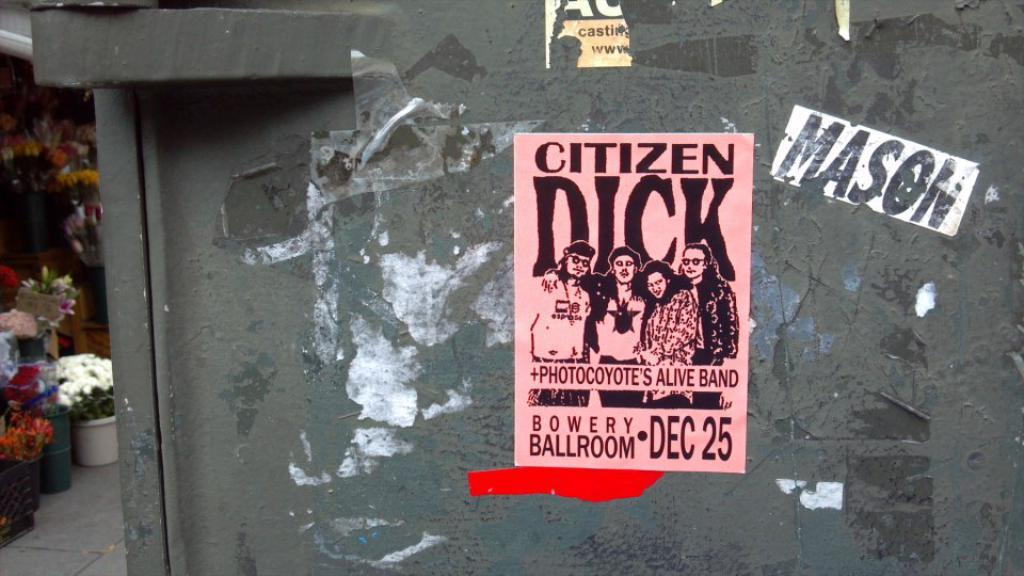<image>
Offer a succinct explanation of the picture presented. an ad poster for CITIZEN DICK + PHOTOCOYOTE'S ALIVE BAND at the BOWERY BALLROOM DEC 25 and a name MASON on the right of it.. 